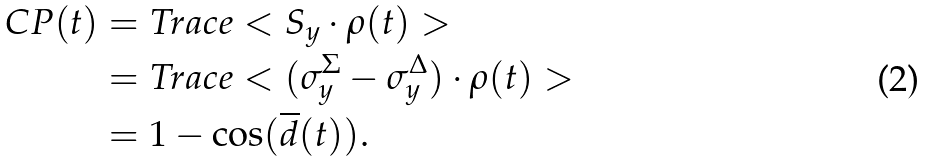<formula> <loc_0><loc_0><loc_500><loc_500>C P ( t ) & = T r a c e < S _ { y } \cdot \rho ( t ) > \\ & = T r a c e < ( \sigma _ { y } ^ { \Sigma } - \sigma _ { y } ^ { \Delta } ) \cdot \rho ( t ) > \\ & = 1 - \cos ( \overline { d } ( t ) ) .</formula> 